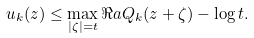Convert formula to latex. <formula><loc_0><loc_0><loc_500><loc_500>u _ { k } ( z ) \leq \max _ { | \zeta | = t } \Re a Q _ { k } ( z + \zeta ) - \log t .</formula> 